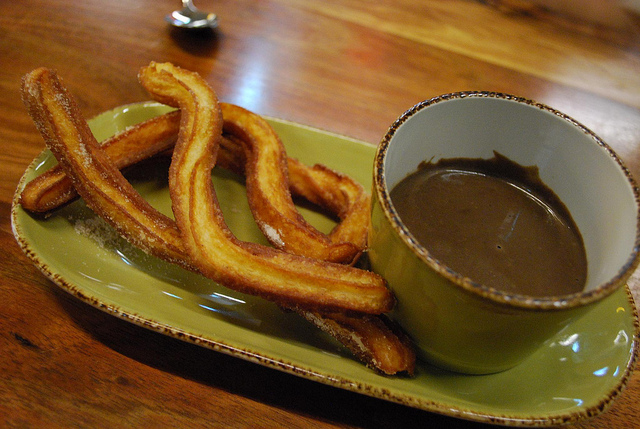If this were a scene in a movie, what kind of scene would it be and why? This scene could be from a cozy, romantic movie where the characters are enjoying a quiet breakfast or dessert in a charming café. The wooden table and the simplicity of the churros and chocolate suggest an intimate and relaxed setting, perfect for heartfelt conversations and forming deeper connections. Create a whimsical story involving these churros. Once upon a time in a quaint little bakery, there were magical churros that could dance! Every night after the bakery closed, the churros would leap off their plates and perform a spectacular dance under the moonlight. One day, a little girl named Emily discovered their secret and promised not to tell anyone. In return, the churros taught her their whimsical dance moves, and together, they danced every night, creating a magical bond that lasted forever. 